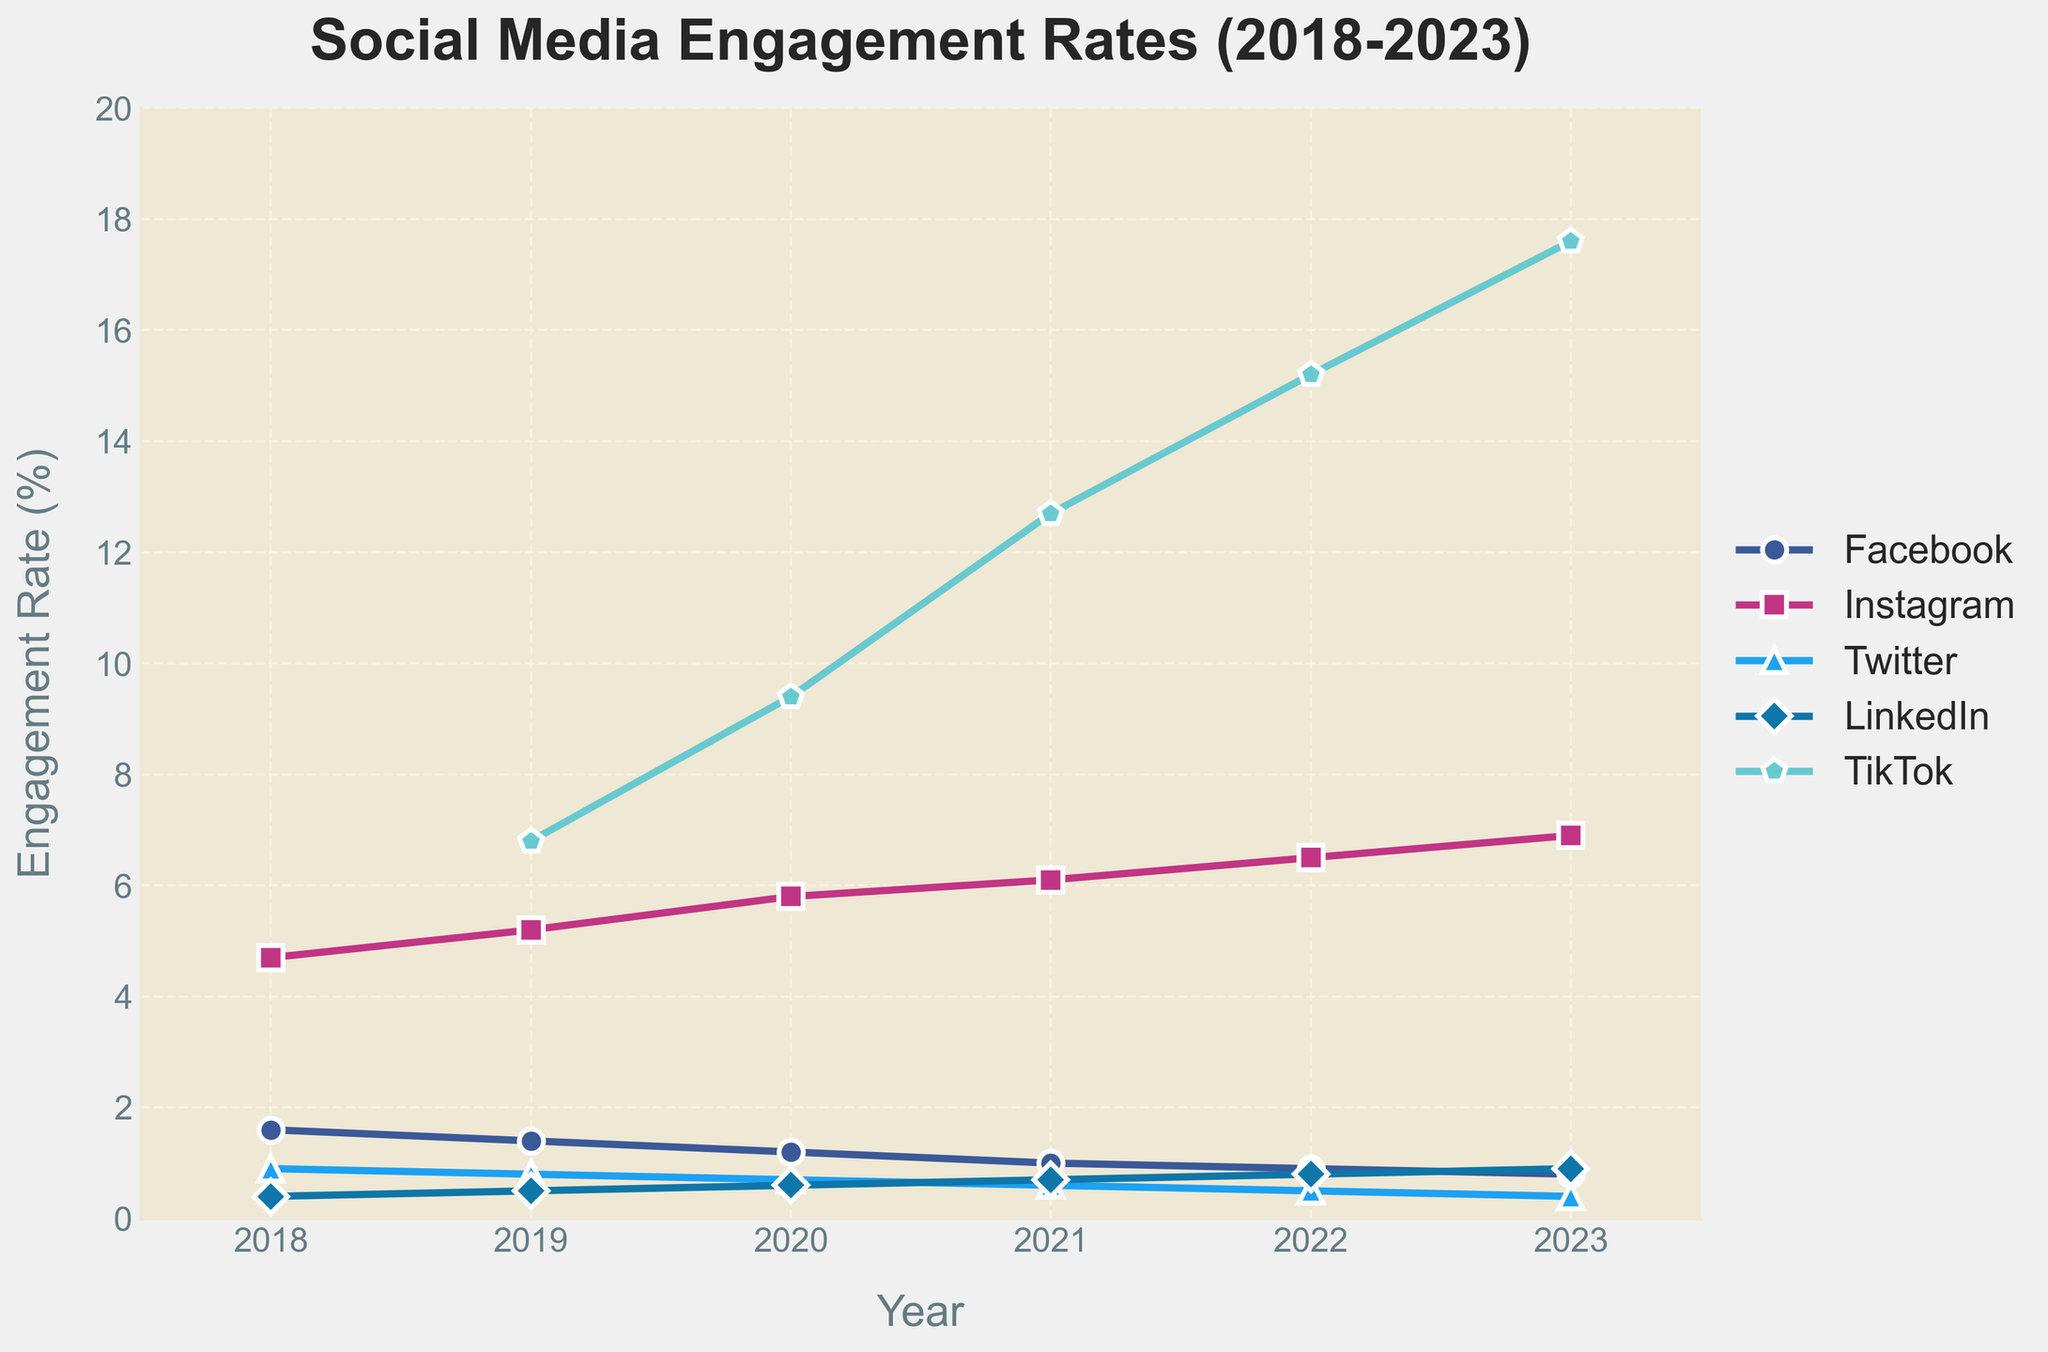Which social media platform experienced the highest increase in engagement rates from 2019 to 2023? First, identify the engagement rates for each platform in 2019 and 2023. Then, subtract the 2019 rates from the 2023 rates. TikTok increased from 6.8% in 2019 to 17.6% in 2023, resulting in an increase of 17.6% - 6.8% = 10.8%.
Answer: TikTok Between Facebook and LinkedIn, which platform had a consistently lower engagement rate over the years? Compare the engagement rates of Facebook and LinkedIn for each year from 2018 through 2023. Facebook rates started at 1.6% and declined to 0.8%, while LinkedIn rates started at 0.4% and increased to 0.9%. From 2018 to 2019, Facebook had higher engagement rates, but LinkedIn's rates surpassed Facebook's from 2021 onwards.
Answer: LinkedIn (2018-2020), Facebook (2021-2023) What is the overall trend in engagement rates for Instagram from 2018 to 2023? Observe the engagement rate data points for Instagram over the years. Instagram rates increased steadily from 4.7% in 2018 to 6.9% in 2023.
Answer: Increasing Which year saw the lowest engagement rate for Twitter? Identify Twitter's engagement rates for each year from 2018 to 2023 and find the minimum value. The rates were 0.9%, 0.8%, 0.7%, 0.6%, 0.5%, and 0.4% respectively, with the lowest being 0.4% in 2023.
Answer: 2023 What is the average engagement rate for LinkedIn from 2018 to 2023? Sum the annual engagement rates for LinkedIn from 2018 to 2023 and divide by the number of years. The rates are 0.4%, 0.5%, 0.6%, 0.7%, 0.8%, and 0.9%. The sum is 4.3%, and the average is 4.3% / 6 ≈ 0.717%.
Answer: 0.717% In 2022, which platform had the highest engagement rate? Check the engagement rates for all platforms in 2022. The rates are Facebook 0.9%, Instagram 6.5%, Twitter 0.5%, LinkedIn 0.8%, and TikTok 15.2%. TikTok had the highest rate in 2022.
Answer: TikTok How did the engagement rate for Facebook change from 2018 to 2023? Identify the engagement rates for Facebook in 2018 (1.6%) and 2023 (0.8%). Subtract the 2023 rate from the 2018 rate: 1.6% - 0.8% = 0.8%. The rate decreased by 0.8%.
Answer: Decreased Which two platforms had equal engagement rates in any given year and what was the rate? Compare the engagement rates for all platforms year by year. In 2020, LinkedIn and Twitter both had a rate of 0.6%.
Answer: LinkedIn and Twitter in 2020 with 0.6% Across how many years did TikTok's engagement rate appear in the data? TikTok's data starts appearing from 2019 onwards. Count the number of years from 2019 to 2023, which is five years.
Answer: Five years In which year did Instagram have the largest annual increase in engagement rate? Calculate the annual differences in engagement rates for Instagram: 
2019-2018: 5.2% - 4.7% = 0.5%
2020-2019: 5.8% - 5.2% = 0.6%
2021-2020: 6.1% - 5.8% = 0.3%
2022-2021: 6.5% - 6.1% = 0.4%
2023-2022: 6.9% - 6.5% = 0.4%
The largest increase was 0.6% from 2019 to 2020.
Answer: 2020 